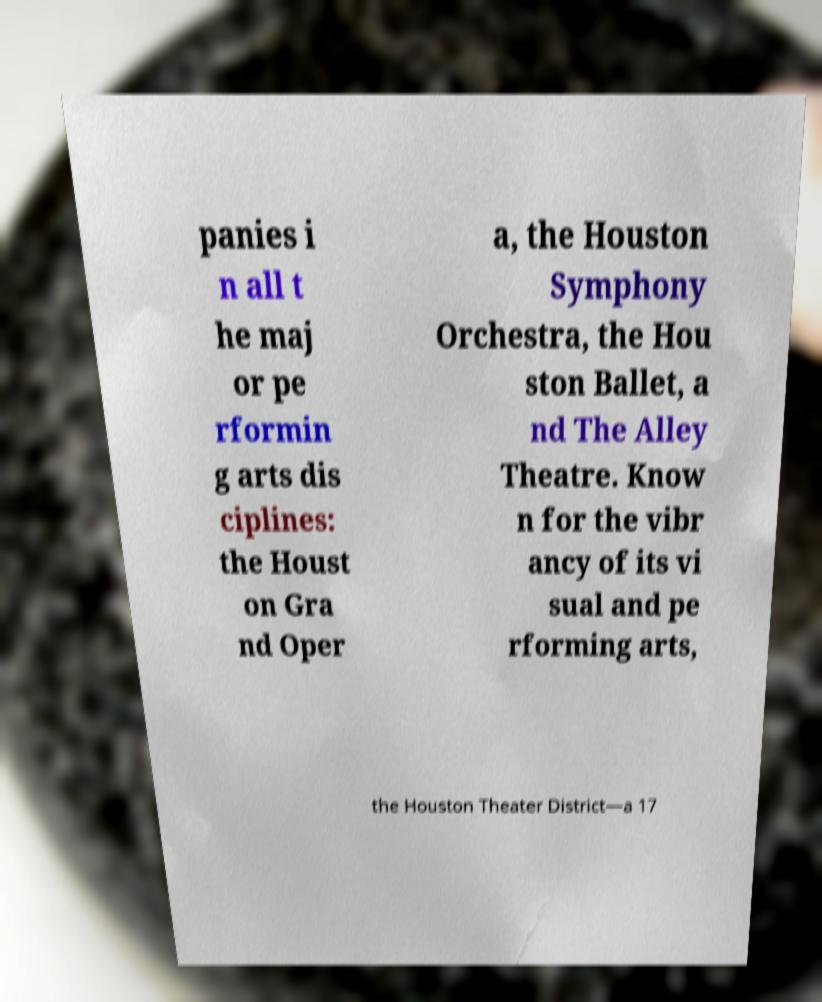I need the written content from this picture converted into text. Can you do that? panies i n all t he maj or pe rformin g arts dis ciplines: the Houst on Gra nd Oper a, the Houston Symphony Orchestra, the Hou ston Ballet, a nd The Alley Theatre. Know n for the vibr ancy of its vi sual and pe rforming arts, the Houston Theater District—a 17 